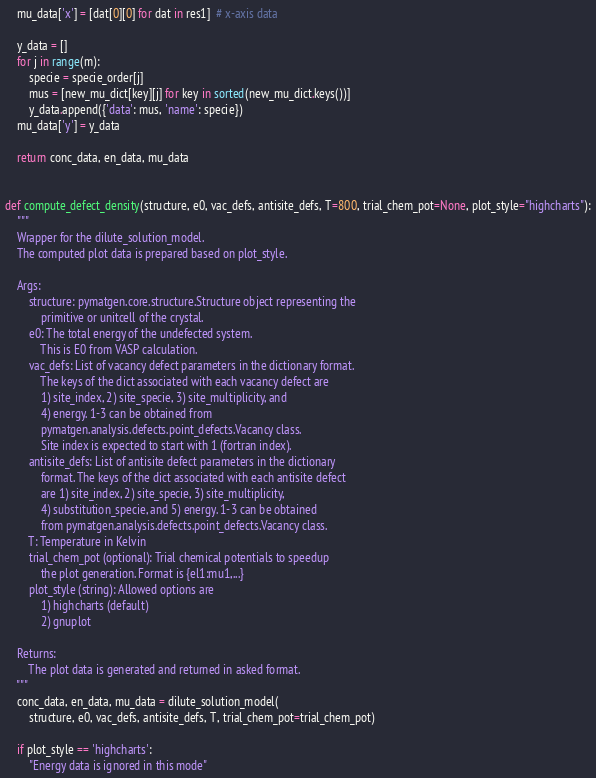<code> <loc_0><loc_0><loc_500><loc_500><_Python_>    mu_data['x'] = [dat[0][0] for dat in res1]  # x-axis data

    y_data = []
    for j in range(m):
        specie = specie_order[j]
        mus = [new_mu_dict[key][j] for key in sorted(new_mu_dict.keys())]
        y_data.append({'data': mus, 'name': specie})
    mu_data['y'] = y_data

    return conc_data, en_data, mu_data


def compute_defect_density(structure, e0, vac_defs, antisite_defs, T=800, trial_chem_pot=None, plot_style="highcharts"):
    """
    Wrapper for the dilute_solution_model.
    The computed plot data is prepared based on plot_style.

    Args:
        structure: pymatgen.core.structure.Structure object representing the
            primitive or unitcell of the crystal.
        e0: The total energy of the undefected system.
            This is E0 from VASP calculation.
        vac_defs: List of vacancy defect parameters in the dictionary format.
            The keys of the dict associated with each vacancy defect are
            1) site_index, 2) site_specie, 3) site_multiplicity, and
            4) energy. 1-3 can be obtained from
            pymatgen.analysis.defects.point_defects.Vacancy class.
            Site index is expected to start with 1 (fortran index).
        antisite_defs: List of antisite defect parameters in the dictionary
            format. The keys of the dict associated with each antisite defect
            are 1) site_index, 2) site_specie, 3) site_multiplicity,
            4) substitution_specie, and 5) energy. 1-3 can be obtained
            from pymatgen.analysis.defects.point_defects.Vacancy class.
        T: Temperature in Kelvin
        trial_chem_pot (optional): Trial chemical potentials to speedup
            the plot generation. Format is {el1:mu1,...}
        plot_style (string): Allowed options are
            1) highcharts (default)
            2) gnuplot

    Returns:
        The plot data is generated and returned in asked format.
    """
    conc_data, en_data, mu_data = dilute_solution_model(
        structure, e0, vac_defs, antisite_defs, T, trial_chem_pot=trial_chem_pot)

    if plot_style == 'highcharts':
        "Energy data is ignored in this mode"</code> 